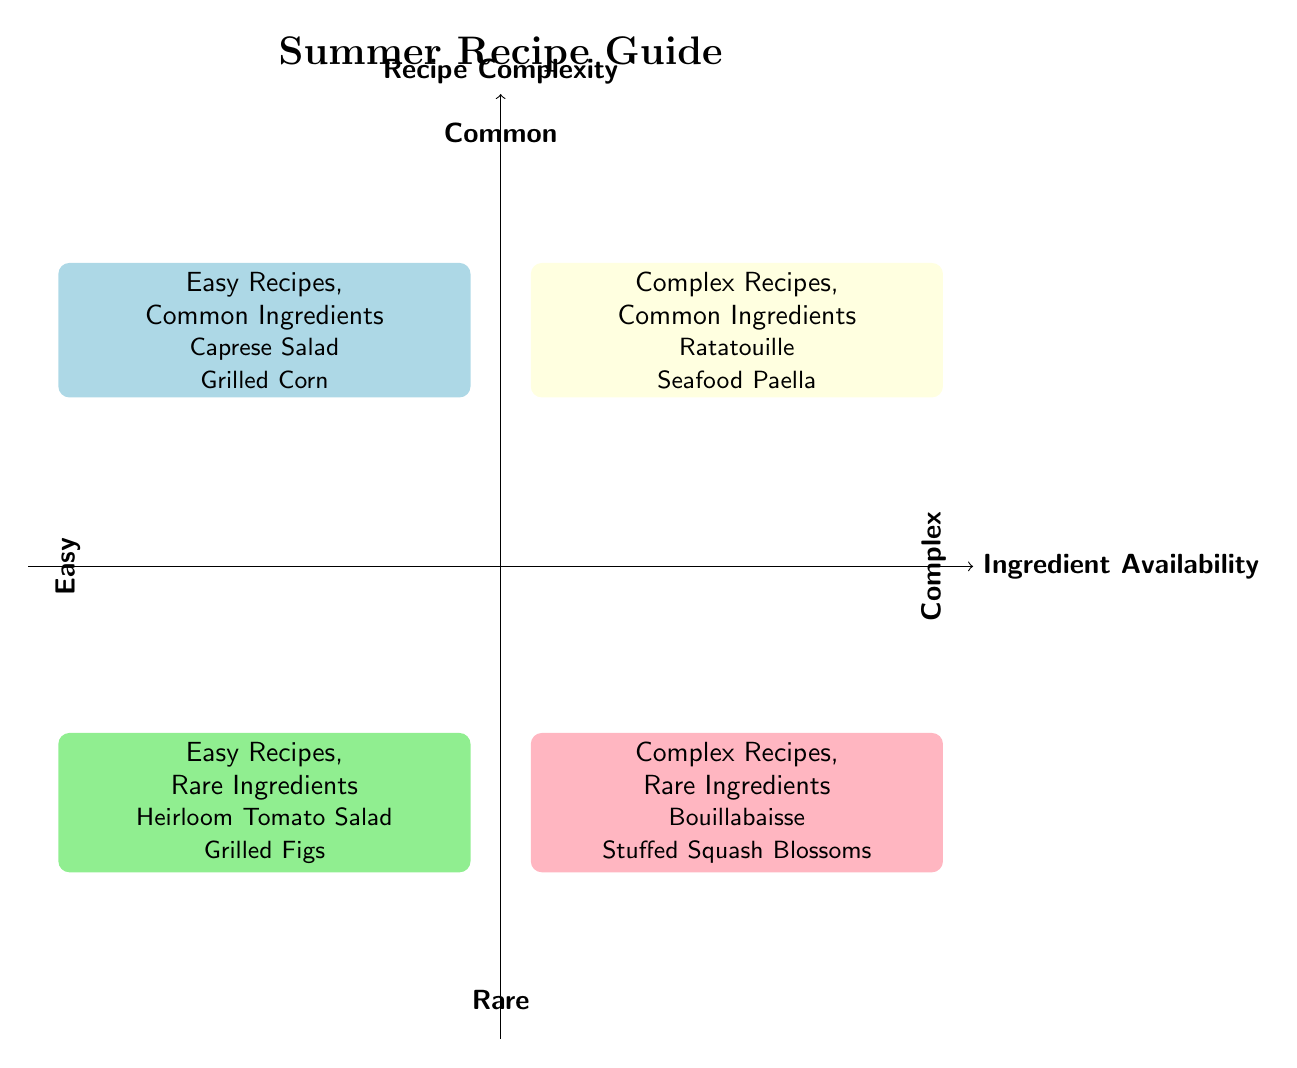What are the names of the two recipes in the "Easy Recipes, Common Ingredients" quadrant? The "Easy Recipes, Common Ingredients" quadrant lists "Caprese Salad" and "Grilled Corn on the Cob."
Answer: Caprese Salad, Grilled Corn on the Cob How many examples of recipes are listed in the "Complex Recipes, Rare Ingredients" quadrant? The "Complex Recipes, Rare Ingredients" quadrant contains two examples: "Bouillabaisse" and "Stuffed Squash Blossoms."
Answer: 2 Which recipe has rare ingredients but is categorized as easy? The "Easy Recipes, Rare Ingredients" quadrant includes "Heirloom Tomato Salad" and "Grilled Figs with Honey," which are both easy.
Answer: Heirloom Tomato Salad, Grilled Figs In the "Complex Recipes, Common Ingredients" quadrant, name one ingredient used in "Seafood Paella." "Seafood Paella" includes several ingredients, one of which is "Rice."
Answer: Rice Which quadrant features recipes with complex methodologies but utilizes common ingredients? The quadrant that includes complex recipes with common ingredients is "Complex Recipes, Common Ingredients," which features "Ratatouille" and "Seafood Paella."
Answer: Complex Recipes, Common Ingredients What type of recipe is predominantly featured in the lower left quadrant? The lower left quadrant contains "Easy Recipes, Rare Ingredients," primarily focusing on easier-to-make recipes using less common ingredients.
Answer: Easy Recipes, Rare Ingredients Which two ingredients are common in both "Ratatouille" and "Seafood Paella"? Both recipes include ingredients such as "Tomatoes" and "Bell Peppers," making them common across this quadrant.
Answer: Tomatoes, Bell Peppers How many quadrants are represented in this chart? The diagram displays four distinct quadrants, each representing a specific relationship between ingredient availability and recipe complexity.
Answer: 4 